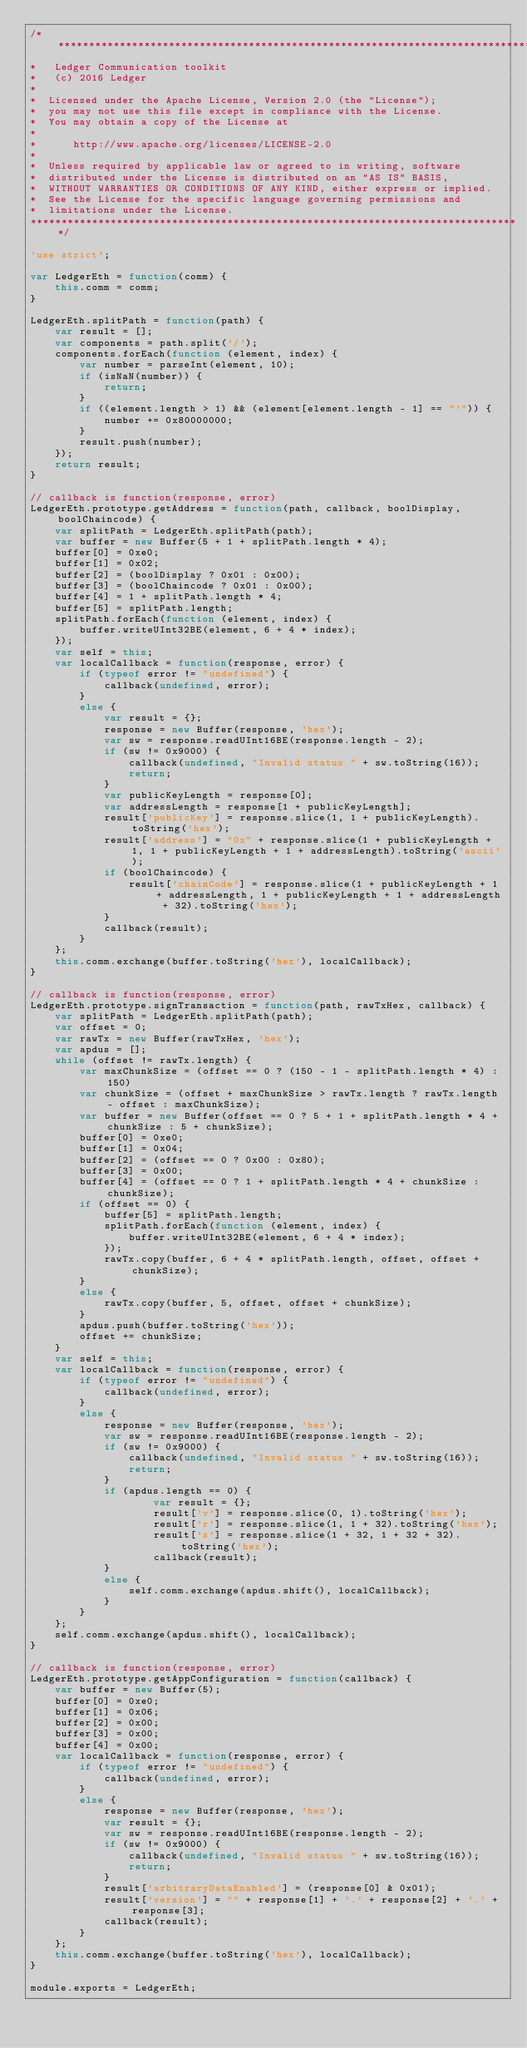Convert code to text. <code><loc_0><loc_0><loc_500><loc_500><_JavaScript_>/********************************************************************************
*   Ledger Communication toolkit
*   (c) 2016 Ledger
*
*  Licensed under the Apache License, Version 2.0 (the "License");
*  you may not use this file except in compliance with the License.
*  You may obtain a copy of the License at
*
*      http://www.apache.org/licenses/LICENSE-2.0
*
*  Unless required by applicable law or agreed to in writing, software
*  distributed under the License is distributed on an "AS IS" BASIS,
*  WITHOUT WARRANTIES OR CONDITIONS OF ANY KIND, either express or implied.
*  See the License for the specific language governing permissions and
*  limitations under the License.
********************************************************************************/

'use strict';

var LedgerEth = function(comm) {
	this.comm = comm;
}

LedgerEth.splitPath = function(path) {
	var result = [];
	var components = path.split('/');
	components.forEach(function (element, index) {
		var number = parseInt(element, 10);
		if (isNaN(number)) {
			return;
		}
		if ((element.length > 1) && (element[element.length - 1] == "'")) {
			number += 0x80000000;
		}
		result.push(number);
	});
	return result;
}

// callback is function(response, error)
LedgerEth.prototype.getAddress = function(path, callback, boolDisplay, boolChaincode) {
	var splitPath = LedgerEth.splitPath(path);
	var buffer = new Buffer(5 + 1 + splitPath.length * 4);
	buffer[0] = 0xe0;
	buffer[1] = 0x02;
	buffer[2] = (boolDisplay ? 0x01 : 0x00);
	buffer[3] = (boolChaincode ? 0x01 : 0x00);
	buffer[4] = 1 + splitPath.length * 4;
	buffer[5] = splitPath.length;
	splitPath.forEach(function (element, index) {
		buffer.writeUInt32BE(element, 6 + 4 * index);
	});
	var self = this;
	var localCallback = function(response, error) {
		if (typeof error != "undefined") {
			callback(undefined, error);
		}
		else {
			var result = {};
			response = new Buffer(response, 'hex');
			var sw = response.readUInt16BE(response.length - 2);
			if (sw != 0x9000) {
				callback(undefined, "Invalid status " + sw.toString(16));
				return;
			}			
			var publicKeyLength = response[0];
			var addressLength = response[1 + publicKeyLength];
			result['publicKey'] = response.slice(1, 1 + publicKeyLength).toString('hex');
			result['address'] = "0x" + response.slice(1 + publicKeyLength + 1, 1 + publicKeyLength + 1 + addressLength).toString('ascii');
			if (boolChaincode) {
				result['chainCode'] = response.slice(1 + publicKeyLength + 1 + addressLength, 1 + publicKeyLength + 1 + addressLength + 32).toString('hex');
			}
			callback(result);
		}
	};
	this.comm.exchange(buffer.toString('hex'), localCallback);
}

// callback is function(response, error)
LedgerEth.prototype.signTransaction = function(path, rawTxHex, callback) {
	var splitPath = LedgerEth.splitPath(path);
	var offset = 0;
	var rawTx = new Buffer(rawTxHex, 'hex');
	var apdus = [];
	while (offset != rawTx.length) {
		var maxChunkSize = (offset == 0 ? (150 - 1 - splitPath.length * 4) : 150)
		var chunkSize = (offset + maxChunkSize > rawTx.length ? rawTx.length - offset : maxChunkSize);
		var buffer = new Buffer(offset == 0 ? 5 + 1 + splitPath.length * 4 + chunkSize : 5 + chunkSize);
		buffer[0] = 0xe0;
		buffer[1] = 0x04;
		buffer[2] = (offset == 0 ? 0x00 : 0x80);
		buffer[3] = 0x00;
		buffer[4] = (offset == 0 ? 1 + splitPath.length * 4 + chunkSize : chunkSize);
		if (offset == 0) {
			buffer[5] = splitPath.length;
			splitPath.forEach(function (element, index) {
				buffer.writeUInt32BE(element, 6 + 4 * index);
			});
			rawTx.copy(buffer, 6 + 4 * splitPath.length, offset, offset + chunkSize);
		}
		else {
			rawTx.copy(buffer, 5, offset, offset + chunkSize);
		}
		apdus.push(buffer.toString('hex'));
		offset += chunkSize;
	}
	var self = this;
	var localCallback = function(response, error) {
		if (typeof error != "undefined") {
			callback(undefined, error);
		}
		else {
			response = new Buffer(response, 'hex');
			var sw = response.readUInt16BE(response.length - 2);
			if (sw != 0x9000) {
				callback(undefined, "Invalid status " + sw.toString(16));
				return;
			}			
			if (apdus.length == 0) {
					var result = {};					
					result['v'] = response.slice(0, 1).toString('hex');
					result['r'] = response.slice(1, 1 + 32).toString('hex');
					result['s'] = response.slice(1 + 32, 1 + 32 + 32).toString('hex');
					callback(result);
			}
			else {
				self.comm.exchange(apdus.shift(), localCallback);
			}
		}
	};
	self.comm.exchange(apdus.shift(), localCallback);
}

// callback is function(response, error)
LedgerEth.prototype.getAppConfiguration = function(callback) {
	var buffer = new Buffer(5);
	buffer[0] = 0xe0;
	buffer[1] = 0x06;
	buffer[2] = 0x00;
	buffer[3] = 0x00;
	buffer[4] = 0x00;
	var localCallback = function(response, error) {
		if (typeof error != "undefined") {
			callback(undefined, error);
		}
		else {
			response = new Buffer(response, 'hex');
			var result = {};
			var sw = response.readUInt16BE(response.length - 2);
			if (sw != 0x9000) {
				callback(undefined, "Invalid status " + sw.toString(16));
				return;
			}
			result['arbitraryDataEnabled'] = (response[0] & 0x01);
			result['version'] = "" + response[1] + '.' + response[2] + '.' + response[3];
			callback(result);
		}
	};
	this.comm.exchange(buffer.toString('hex'), localCallback);
}

module.exports = LedgerEth;

</code> 